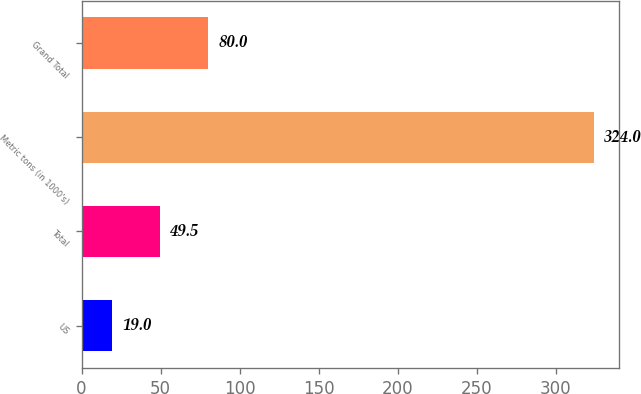<chart> <loc_0><loc_0><loc_500><loc_500><bar_chart><fcel>US<fcel>Total<fcel>Metric tons (in 1000's)<fcel>Grand Total<nl><fcel>19<fcel>49.5<fcel>324<fcel>80<nl></chart> 